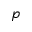<formula> <loc_0><loc_0><loc_500><loc_500>p</formula> 